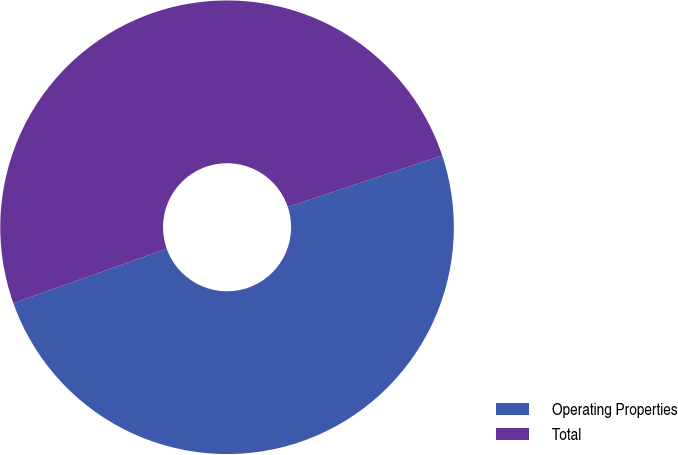Convert chart to OTSL. <chart><loc_0><loc_0><loc_500><loc_500><pie_chart><fcel>Operating Properties<fcel>Total<nl><fcel>49.69%<fcel>50.31%<nl></chart> 